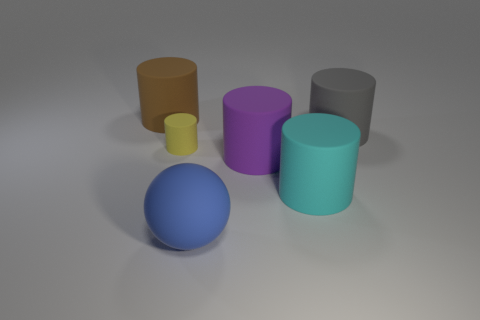Subtract 1 cylinders. How many cylinders are left? 4 Subtract all cyan cylinders. How many cylinders are left? 4 Subtract all big cyan matte cylinders. How many cylinders are left? 4 Subtract all blue cylinders. Subtract all yellow blocks. How many cylinders are left? 5 Add 1 red matte balls. How many objects exist? 7 Subtract all spheres. How many objects are left? 5 Add 2 tiny blue rubber cylinders. How many tiny blue rubber cylinders exist? 2 Subtract 1 purple cylinders. How many objects are left? 5 Subtract all gray cubes. Subtract all cyan objects. How many objects are left? 5 Add 2 blue things. How many blue things are left? 3 